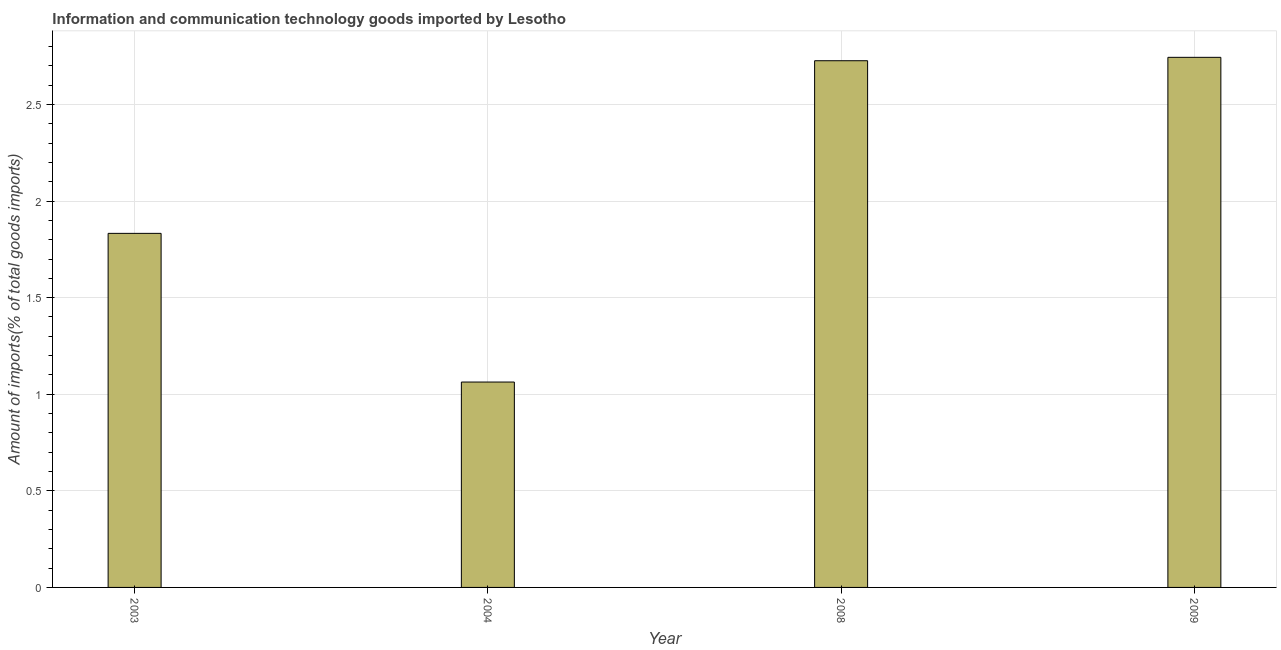What is the title of the graph?
Provide a succinct answer. Information and communication technology goods imported by Lesotho. What is the label or title of the X-axis?
Offer a terse response. Year. What is the label or title of the Y-axis?
Provide a succinct answer. Amount of imports(% of total goods imports). What is the amount of ict goods imports in 2008?
Ensure brevity in your answer.  2.73. Across all years, what is the maximum amount of ict goods imports?
Provide a succinct answer. 2.74. Across all years, what is the minimum amount of ict goods imports?
Give a very brief answer. 1.06. In which year was the amount of ict goods imports maximum?
Keep it short and to the point. 2009. What is the sum of the amount of ict goods imports?
Offer a terse response. 8.37. What is the difference between the amount of ict goods imports in 2003 and 2008?
Offer a terse response. -0.89. What is the average amount of ict goods imports per year?
Your answer should be very brief. 2.09. What is the median amount of ict goods imports?
Your response must be concise. 2.28. In how many years, is the amount of ict goods imports greater than 2.6 %?
Your answer should be compact. 2. What is the ratio of the amount of ict goods imports in 2004 to that in 2009?
Offer a very short reply. 0.39. What is the difference between the highest and the second highest amount of ict goods imports?
Provide a short and direct response. 0.02. What is the difference between the highest and the lowest amount of ict goods imports?
Provide a succinct answer. 1.68. What is the difference between two consecutive major ticks on the Y-axis?
Ensure brevity in your answer.  0.5. What is the Amount of imports(% of total goods imports) in 2003?
Ensure brevity in your answer.  1.83. What is the Amount of imports(% of total goods imports) of 2004?
Your response must be concise. 1.06. What is the Amount of imports(% of total goods imports) in 2008?
Provide a short and direct response. 2.73. What is the Amount of imports(% of total goods imports) of 2009?
Make the answer very short. 2.74. What is the difference between the Amount of imports(% of total goods imports) in 2003 and 2004?
Keep it short and to the point. 0.77. What is the difference between the Amount of imports(% of total goods imports) in 2003 and 2008?
Your response must be concise. -0.89. What is the difference between the Amount of imports(% of total goods imports) in 2003 and 2009?
Ensure brevity in your answer.  -0.91. What is the difference between the Amount of imports(% of total goods imports) in 2004 and 2008?
Provide a succinct answer. -1.66. What is the difference between the Amount of imports(% of total goods imports) in 2004 and 2009?
Offer a very short reply. -1.68. What is the difference between the Amount of imports(% of total goods imports) in 2008 and 2009?
Give a very brief answer. -0.02. What is the ratio of the Amount of imports(% of total goods imports) in 2003 to that in 2004?
Keep it short and to the point. 1.72. What is the ratio of the Amount of imports(% of total goods imports) in 2003 to that in 2008?
Offer a terse response. 0.67. What is the ratio of the Amount of imports(% of total goods imports) in 2003 to that in 2009?
Your answer should be compact. 0.67. What is the ratio of the Amount of imports(% of total goods imports) in 2004 to that in 2008?
Make the answer very short. 0.39. What is the ratio of the Amount of imports(% of total goods imports) in 2004 to that in 2009?
Give a very brief answer. 0.39. What is the ratio of the Amount of imports(% of total goods imports) in 2008 to that in 2009?
Ensure brevity in your answer.  0.99. 